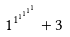Convert formula to latex. <formula><loc_0><loc_0><loc_500><loc_500>1 ^ { 1 ^ { 1 ^ { 1 ^ { 1 ^ { 1 } } } } } + 3</formula> 